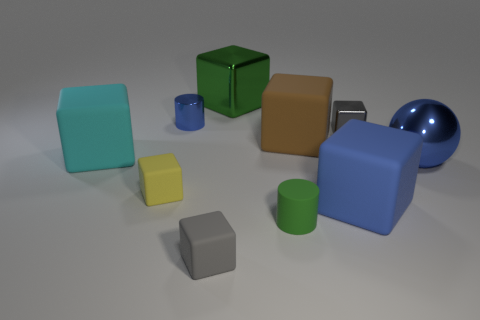Subtract all shiny cubes. How many cubes are left? 5 Subtract all brown balls. How many gray cubes are left? 2 Subtract all cyan blocks. How many blocks are left? 6 Subtract all cubes. How many objects are left? 3 Subtract 1 blocks. How many blocks are left? 6 Subtract all green blocks. Subtract all red cylinders. How many blocks are left? 6 Subtract all tiny gray shiny objects. Subtract all blue metallic cylinders. How many objects are left? 8 Add 1 large blue matte cubes. How many large blue matte cubes are left? 2 Add 9 red blocks. How many red blocks exist? 9 Subtract 0 brown cylinders. How many objects are left? 10 